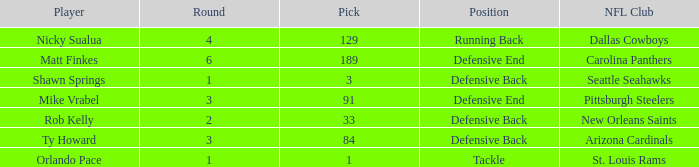What is the lowest pick that has arizona cardinals as the NFL club? 84.0. Would you mind parsing the complete table? {'header': ['Player', 'Round', 'Pick', 'Position', 'NFL Club'], 'rows': [['Nicky Sualua', '4', '129', 'Running Back', 'Dallas Cowboys'], ['Matt Finkes', '6', '189', 'Defensive End', 'Carolina Panthers'], ['Shawn Springs', '1', '3', 'Defensive Back', 'Seattle Seahawks'], ['Mike Vrabel', '3', '91', 'Defensive End', 'Pittsburgh Steelers'], ['Rob Kelly', '2', '33', 'Defensive Back', 'New Orleans Saints'], ['Ty Howard', '3', '84', 'Defensive Back', 'Arizona Cardinals'], ['Orlando Pace', '1', '1', 'Tackle', 'St. Louis Rams']]} 